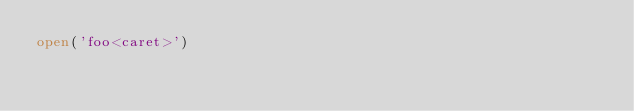<code> <loc_0><loc_0><loc_500><loc_500><_Python_>open('foo<caret>')
</code> 